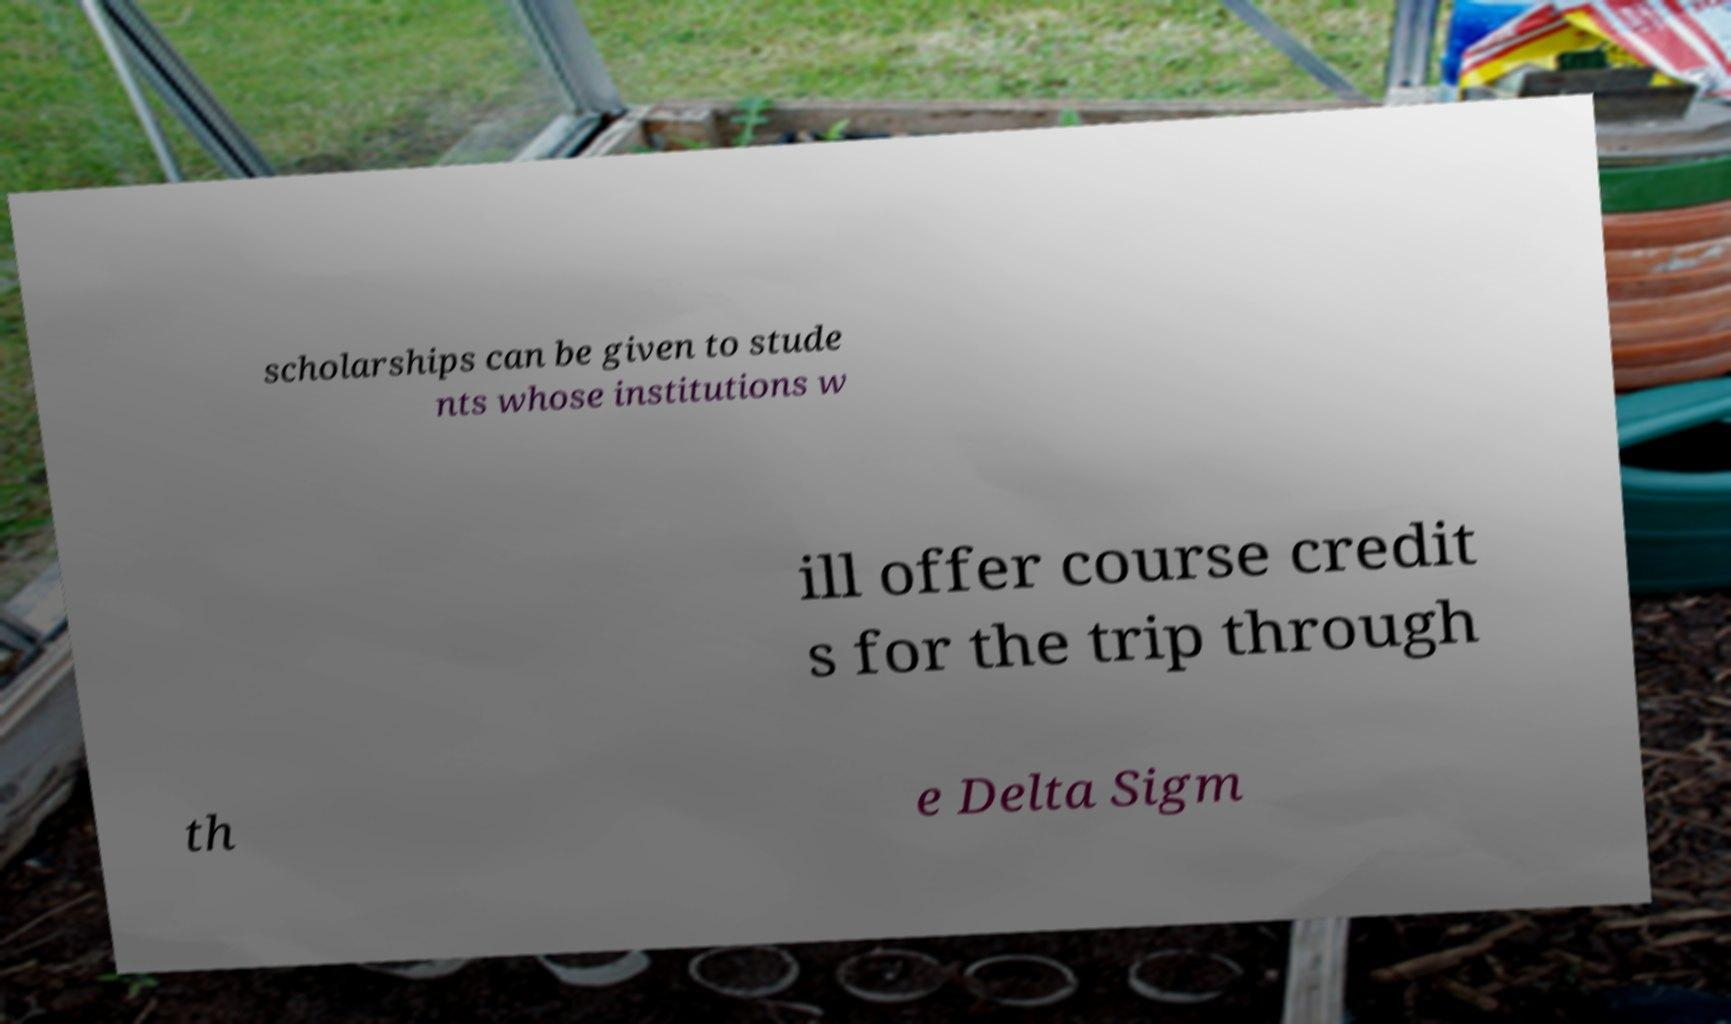There's text embedded in this image that I need extracted. Can you transcribe it verbatim? scholarships can be given to stude nts whose institutions w ill offer course credit s for the trip through th e Delta Sigm 